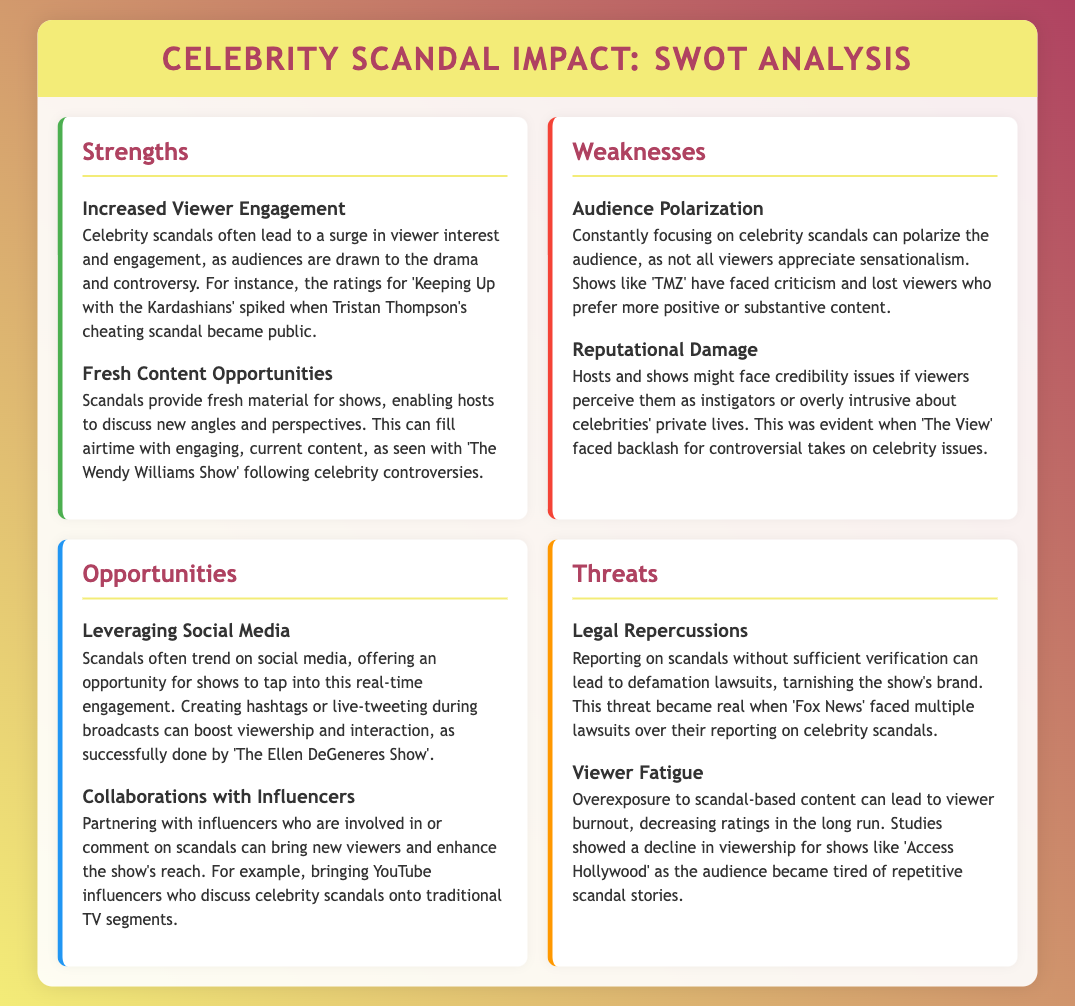What is one strength of celebrity scandals? One strength is increased viewer engagement as audiences are drawn to the drama and controversy.
Answer: Increased Viewer Engagement What is a weakness associated with focusing on celebrity scandals? A weakness is audience polarization, as not all viewers appreciate sensationalism.
Answer: Audience Polarization What is an opportunity for shows when scandals trend on social media? Shows can leverage social media to tap into real-time engagement with viewers.
Answer: Leveraging Social Media What threat can arise from reporting on scandals without verification? Reporting without verification can lead to legal repercussions such as defamation lawsuits.
Answer: Legal Repercussions Which show experienced a spike in ratings during a cheating scandal? The show that experienced a spike in ratings is 'Keeping Up with the Kardashians'.
Answer: 'Keeping Up with the Kardashians' What activity can enhance a show's reach by collaborating with influencers? Partnering with influencers who comment on scandals can bring new viewers.
Answer: Collaborations with Influencers What consequence did 'TMZ' face due to its focus on scandals? 'TMZ' faced criticism and lost viewers who preferred more positive content.
Answer: Reputational Damage What long-term effect can overexposure to scandal-based content have on viewers? Overexposure can lead to viewer fatigue, causing a decrease in ratings.
Answer: Viewer Fatigue 